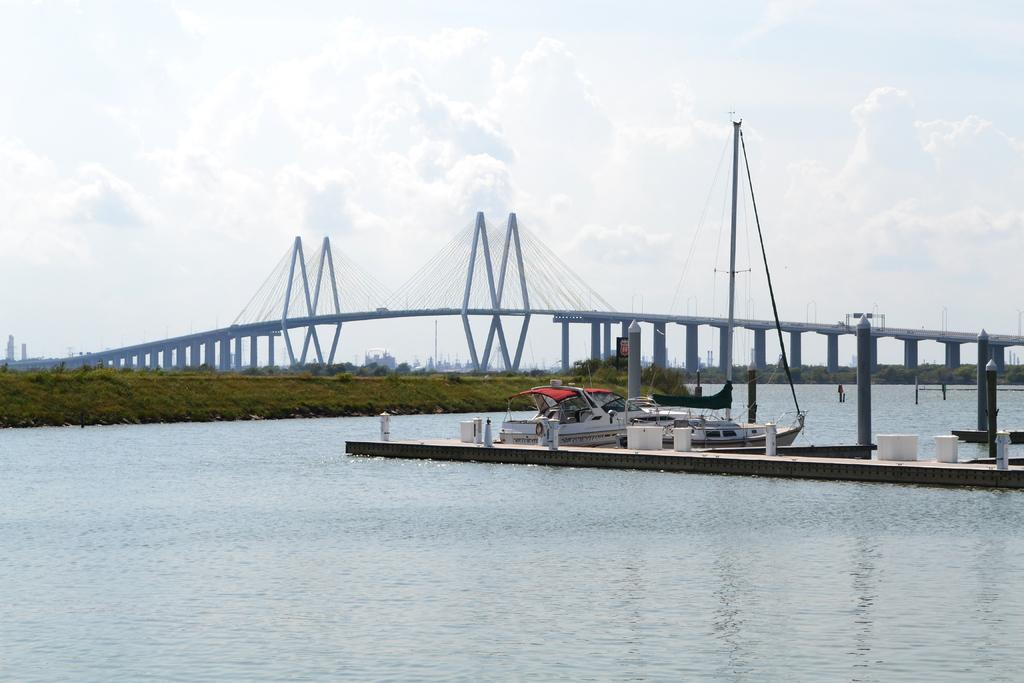What can be seen in the foreground of the image? There is water and a dock in the foreground of the image. What is on the water in the image? There is a boat on the water in the image. What type of landscape is visible in the background of the image? There is grassland and a bridge in the background of the image. What part of the natural environment is visible in the image? The sky is visible in the background of the image. What type of cherry pie can be seen on the edge of the dock in the image? There is no cherry pie present in the image; it features water, a dock, a boat, grassland, a bridge, and the sky. How many cherries are visible on the edge of the dock in the image? There are no cherries visible on the edge of the dock in the image. 